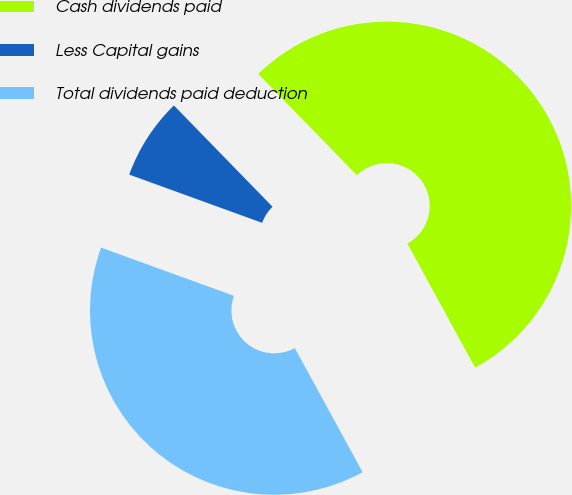Convert chart. <chart><loc_0><loc_0><loc_500><loc_500><pie_chart><fcel>Cash dividends paid<fcel>Less Capital gains<fcel>Total dividends paid deduction<nl><fcel>54.33%<fcel>7.17%<fcel>38.5%<nl></chart> 